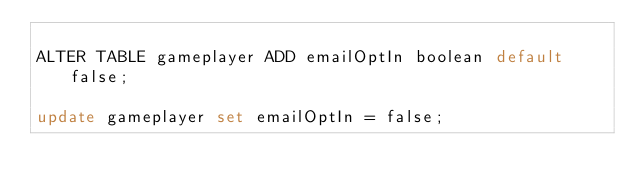Convert code to text. <code><loc_0><loc_0><loc_500><loc_500><_SQL_>
ALTER TABLE gameplayer ADD emailOptIn boolean default false;

update gameplayer set emailOptIn = false;
</code> 